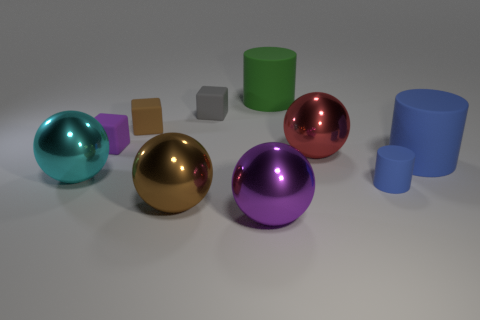What is the material of the red thing that is the same shape as the brown metallic thing?
Your answer should be very brief. Metal. There is a large thing that is to the right of the large green matte cylinder and left of the large blue thing; what is its material?
Ensure brevity in your answer.  Metal. What is the shape of the purple shiny thing?
Your response must be concise. Sphere. How many other objects are there of the same material as the tiny gray thing?
Your answer should be very brief. 5. Is the size of the cyan shiny sphere the same as the brown rubber object?
Your answer should be compact. No. There is a tiny rubber object on the right side of the large green rubber cylinder; what is its shape?
Keep it short and to the point. Cylinder. There is a ball that is on the left side of the small purple thing that is behind the big brown metal object; what color is it?
Make the answer very short. Cyan. There is a metallic thing left of the large brown sphere; does it have the same shape as the rubber thing that is in front of the large cyan thing?
Give a very brief answer. No. The blue thing that is the same size as the brown rubber block is what shape?
Give a very brief answer. Cylinder. The small cylinder that is the same material as the purple block is what color?
Provide a succinct answer. Blue. 